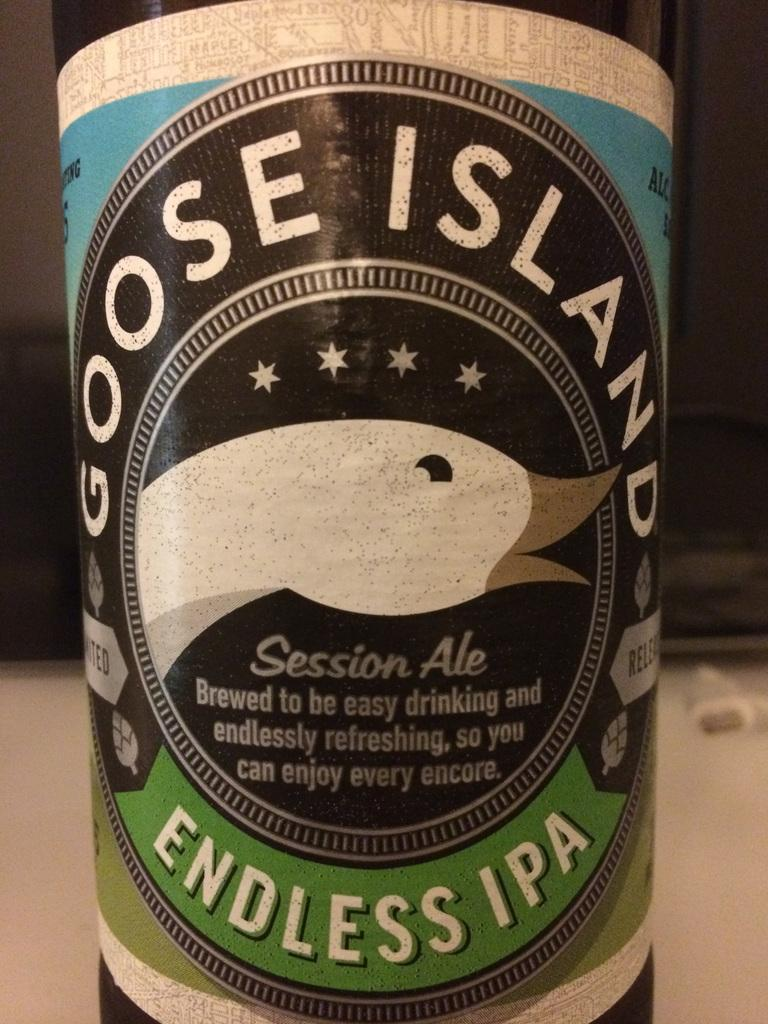<image>
Summarize the visual content of the image. Goose Island Endless Ipa bottle advertising that it is brewed for an easy drinking and refreshing experience. 